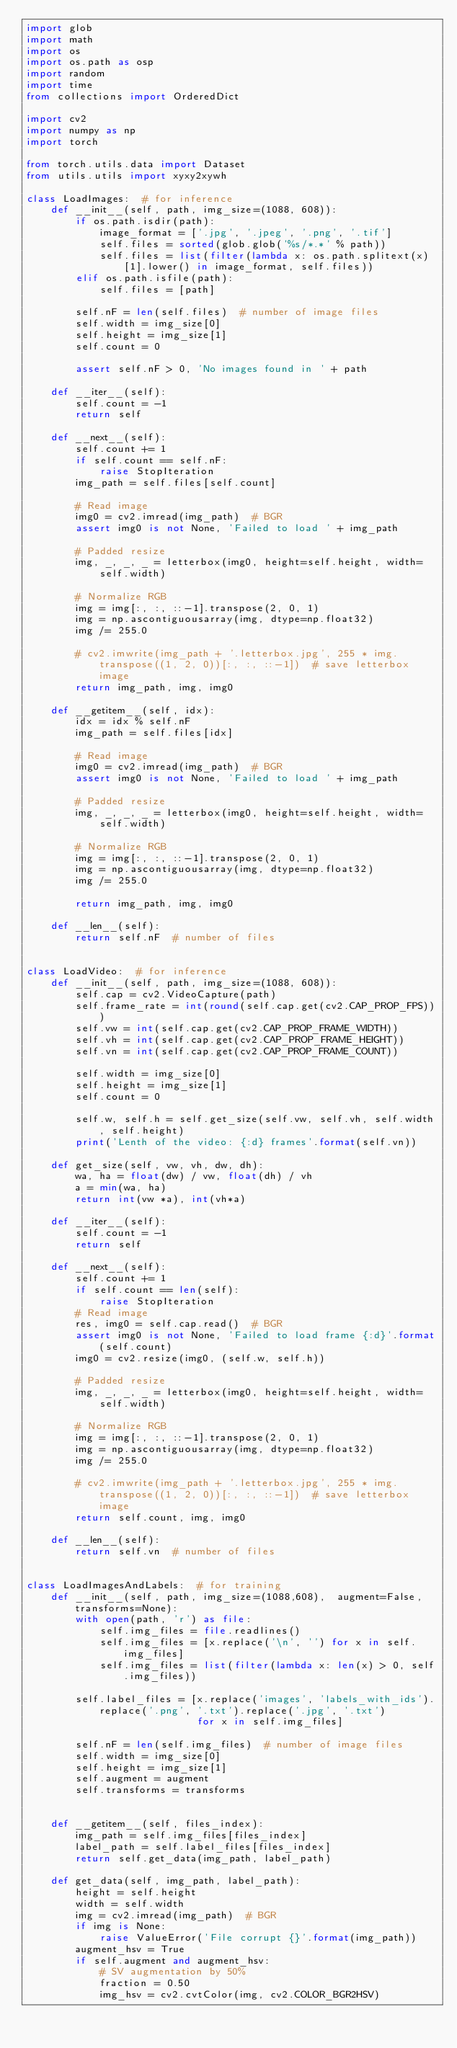<code> <loc_0><loc_0><loc_500><loc_500><_Python_>import glob
import math
import os
import os.path as osp
import random
import time
from collections import OrderedDict

import cv2
import numpy as np
import torch

from torch.utils.data import Dataset
from utils.utils import xyxy2xywh

class LoadImages:  # for inference
    def __init__(self, path, img_size=(1088, 608)):
        if os.path.isdir(path):
            image_format = ['.jpg', '.jpeg', '.png', '.tif']
            self.files = sorted(glob.glob('%s/*.*' % path))
            self.files = list(filter(lambda x: os.path.splitext(x)[1].lower() in image_format, self.files))
        elif os.path.isfile(path):
            self.files = [path]

        self.nF = len(self.files)  # number of image files
        self.width = img_size[0]
        self.height = img_size[1]
        self.count = 0

        assert self.nF > 0, 'No images found in ' + path

    def __iter__(self):
        self.count = -1
        return self

    def __next__(self):
        self.count += 1
        if self.count == self.nF:
            raise StopIteration
        img_path = self.files[self.count]

        # Read image
        img0 = cv2.imread(img_path)  # BGR
        assert img0 is not None, 'Failed to load ' + img_path

        # Padded resize
        img, _, _, _ = letterbox(img0, height=self.height, width=self.width)

        # Normalize RGB
        img = img[:, :, ::-1].transpose(2, 0, 1)
        img = np.ascontiguousarray(img, dtype=np.float32)
        img /= 255.0

        # cv2.imwrite(img_path + '.letterbox.jpg', 255 * img.transpose((1, 2, 0))[:, :, ::-1])  # save letterbox image
        return img_path, img, img0
    
    def __getitem__(self, idx):
        idx = idx % self.nF 
        img_path = self.files[idx]

        # Read image
        img0 = cv2.imread(img_path)  # BGR
        assert img0 is not None, 'Failed to load ' + img_path

        # Padded resize
        img, _, _, _ = letterbox(img0, height=self.height, width=self.width)

        # Normalize RGB
        img = img[:, :, ::-1].transpose(2, 0, 1)
        img = np.ascontiguousarray(img, dtype=np.float32)
        img /= 255.0

        return img_path, img, img0

    def __len__(self):
        return self.nF  # number of files


class LoadVideo:  # for inference
    def __init__(self, path, img_size=(1088, 608)):
        self.cap = cv2.VideoCapture(path)        
        self.frame_rate = int(round(self.cap.get(cv2.CAP_PROP_FPS)))
        self.vw = int(self.cap.get(cv2.CAP_PROP_FRAME_WIDTH))
        self.vh = int(self.cap.get(cv2.CAP_PROP_FRAME_HEIGHT))
        self.vn = int(self.cap.get(cv2.CAP_PROP_FRAME_COUNT))

        self.width = img_size[0]
        self.height = img_size[1]
        self.count = 0

        self.w, self.h = self.get_size(self.vw, self.vh, self.width, self.height)
        print('Lenth of the video: {:d} frames'.format(self.vn))

    def get_size(self, vw, vh, dw, dh):
        wa, ha = float(dw) / vw, float(dh) / vh
        a = min(wa, ha)
        return int(vw *a), int(vh*a)

    def __iter__(self):
        self.count = -1
        return self

    def __next__(self):
        self.count += 1
        if self.count == len(self):
            raise StopIteration
        # Read image
        res, img0 = self.cap.read()  # BGR
        assert img0 is not None, 'Failed to load frame {:d}'.format(self.count)
        img0 = cv2.resize(img0, (self.w, self.h))

        # Padded resize
        img, _, _, _ = letterbox(img0, height=self.height, width=self.width)

        # Normalize RGB
        img = img[:, :, ::-1].transpose(2, 0, 1)
        img = np.ascontiguousarray(img, dtype=np.float32)
        img /= 255.0

        # cv2.imwrite(img_path + '.letterbox.jpg', 255 * img.transpose((1, 2, 0))[:, :, ::-1])  # save letterbox image
        return self.count, img, img0
    
    def __len__(self):
        return self.vn  # number of files


class LoadImagesAndLabels:  # for training
    def __init__(self, path, img_size=(1088,608),  augment=False, transforms=None):
        with open(path, 'r') as file:
            self.img_files = file.readlines()
            self.img_files = [x.replace('\n', '') for x in self.img_files]
            self.img_files = list(filter(lambda x: len(x) > 0, self.img_files))

        self.label_files = [x.replace('images', 'labels_with_ids').replace('.png', '.txt').replace('.jpg', '.txt')
                            for x in self.img_files]

        self.nF = len(self.img_files)  # number of image files
        self.width = img_size[0]
        self.height = img_size[1]
        self.augment = augment
        self.transforms = transforms


    def __getitem__(self, files_index):
        img_path = self.img_files[files_index]
        label_path = self.label_files[files_index]
        return self.get_data(img_path, label_path)

    def get_data(self, img_path, label_path):
        height = self.height
        width = self.width
        img = cv2.imread(img_path)  # BGR
        if img is None:
            raise ValueError('File corrupt {}'.format(img_path))
        augment_hsv = True
        if self.augment and augment_hsv:    
            # SV augmentation by 50%
            fraction = 0.50
            img_hsv = cv2.cvtColor(img, cv2.COLOR_BGR2HSV)</code> 